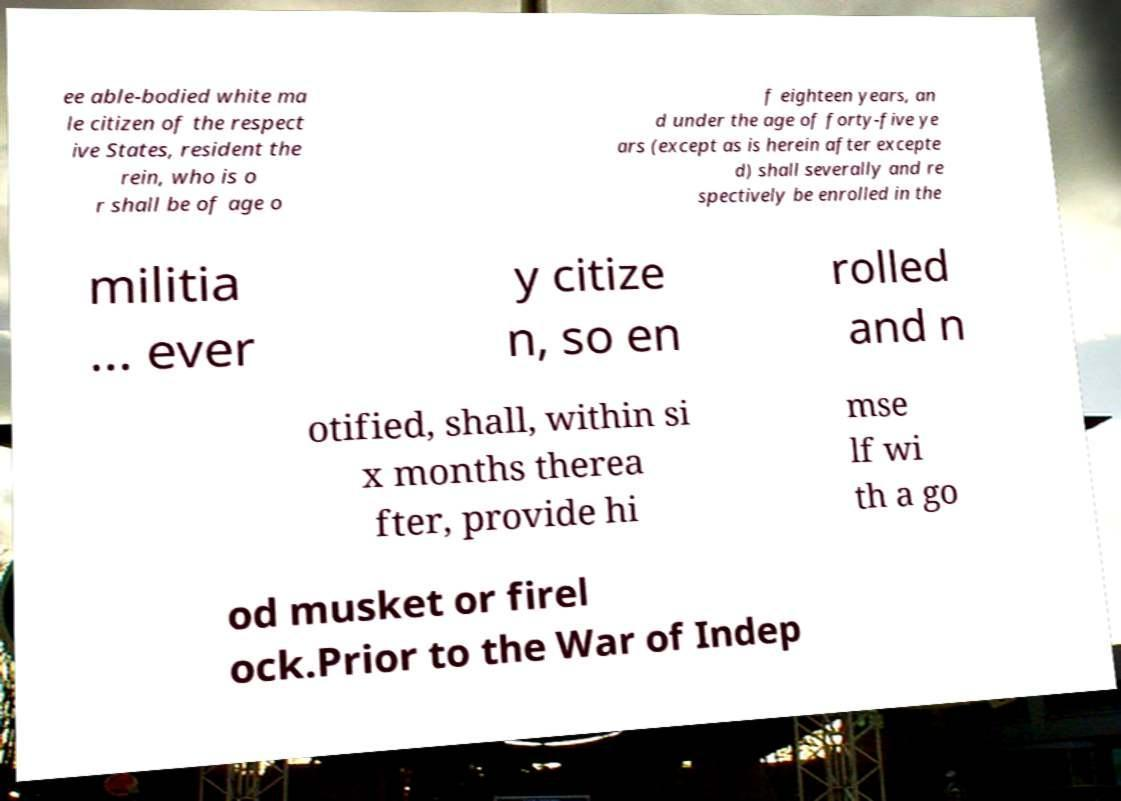Could you assist in decoding the text presented in this image and type it out clearly? ee able-bodied white ma le citizen of the respect ive States, resident the rein, who is o r shall be of age o f eighteen years, an d under the age of forty-five ye ars (except as is herein after excepte d) shall severally and re spectively be enrolled in the militia ... ever y citize n, so en rolled and n otified, shall, within si x months therea fter, provide hi mse lf wi th a go od musket or firel ock.Prior to the War of Indep 